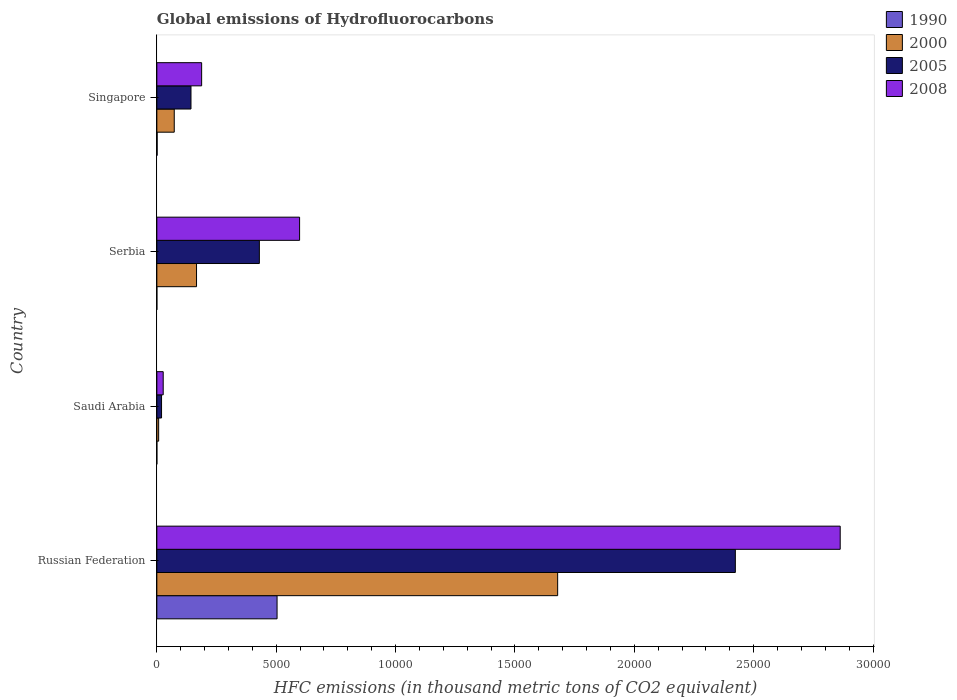Are the number of bars per tick equal to the number of legend labels?
Make the answer very short. Yes. Are the number of bars on each tick of the Y-axis equal?
Your answer should be compact. Yes. How many bars are there on the 2nd tick from the bottom?
Your answer should be compact. 4. What is the label of the 4th group of bars from the top?
Keep it short and to the point. Russian Federation. What is the global emissions of Hydrofluorocarbons in 2005 in Singapore?
Ensure brevity in your answer.  1429.7. Across all countries, what is the maximum global emissions of Hydrofluorocarbons in 2005?
Offer a terse response. 2.42e+04. Across all countries, what is the minimum global emissions of Hydrofluorocarbons in 2005?
Provide a short and direct response. 196.9. In which country was the global emissions of Hydrofluorocarbons in 2008 maximum?
Make the answer very short. Russian Federation. In which country was the global emissions of Hydrofluorocarbons in 2008 minimum?
Provide a succinct answer. Saudi Arabia. What is the total global emissions of Hydrofluorocarbons in 2008 in the graph?
Your response must be concise. 3.67e+04. What is the difference between the global emissions of Hydrofluorocarbons in 1990 in Russian Federation and that in Serbia?
Your answer should be compact. 5035.1. What is the difference between the global emissions of Hydrofluorocarbons in 2005 in Serbia and the global emissions of Hydrofluorocarbons in 1990 in Saudi Arabia?
Provide a succinct answer. 4293.7. What is the average global emissions of Hydrofluorocarbons in 2008 per country?
Your answer should be compact. 9186.35. What is the difference between the global emissions of Hydrofluorocarbons in 2008 and global emissions of Hydrofluorocarbons in 1990 in Saudi Arabia?
Make the answer very short. 266.4. In how many countries, is the global emissions of Hydrofluorocarbons in 2005 greater than 5000 thousand metric tons?
Your response must be concise. 1. What is the ratio of the global emissions of Hydrofluorocarbons in 1990 in Russian Federation to that in Singapore?
Ensure brevity in your answer.  399.65. Is the difference between the global emissions of Hydrofluorocarbons in 2008 in Saudi Arabia and Singapore greater than the difference between the global emissions of Hydrofluorocarbons in 1990 in Saudi Arabia and Singapore?
Your answer should be compact. No. What is the difference between the highest and the second highest global emissions of Hydrofluorocarbons in 2005?
Offer a very short reply. 1.99e+04. What is the difference between the highest and the lowest global emissions of Hydrofluorocarbons in 2005?
Your response must be concise. 2.40e+04. Is the sum of the global emissions of Hydrofluorocarbons in 2005 in Saudi Arabia and Serbia greater than the maximum global emissions of Hydrofluorocarbons in 2000 across all countries?
Your answer should be compact. No. Is it the case that in every country, the sum of the global emissions of Hydrofluorocarbons in 1990 and global emissions of Hydrofluorocarbons in 2008 is greater than the sum of global emissions of Hydrofluorocarbons in 2005 and global emissions of Hydrofluorocarbons in 2000?
Your answer should be compact. Yes. What does the 1st bar from the bottom in Singapore represents?
Keep it short and to the point. 1990. Is it the case that in every country, the sum of the global emissions of Hydrofluorocarbons in 2000 and global emissions of Hydrofluorocarbons in 1990 is greater than the global emissions of Hydrofluorocarbons in 2008?
Provide a short and direct response. No. How many bars are there?
Offer a terse response. 16. How many countries are there in the graph?
Ensure brevity in your answer.  4. What is the difference between two consecutive major ticks on the X-axis?
Make the answer very short. 5000. Does the graph contain any zero values?
Offer a very short reply. No. Does the graph contain grids?
Your answer should be very brief. No. Where does the legend appear in the graph?
Make the answer very short. Top right. How many legend labels are there?
Provide a short and direct response. 4. What is the title of the graph?
Give a very brief answer. Global emissions of Hydrofluorocarbons. What is the label or title of the X-axis?
Offer a very short reply. HFC emissions (in thousand metric tons of CO2 equivalent). What is the HFC emissions (in thousand metric tons of CO2 equivalent) in 1990 in Russian Federation?
Provide a short and direct response. 5035.6. What is the HFC emissions (in thousand metric tons of CO2 equivalent) of 2000 in Russian Federation?
Your response must be concise. 1.68e+04. What is the HFC emissions (in thousand metric tons of CO2 equivalent) in 2005 in Russian Federation?
Ensure brevity in your answer.  2.42e+04. What is the HFC emissions (in thousand metric tons of CO2 equivalent) in 2008 in Russian Federation?
Provide a succinct answer. 2.86e+04. What is the HFC emissions (in thousand metric tons of CO2 equivalent) in 1990 in Saudi Arabia?
Your answer should be very brief. 0.1. What is the HFC emissions (in thousand metric tons of CO2 equivalent) of 2000 in Saudi Arabia?
Offer a terse response. 75.5. What is the HFC emissions (in thousand metric tons of CO2 equivalent) in 2005 in Saudi Arabia?
Offer a terse response. 196.9. What is the HFC emissions (in thousand metric tons of CO2 equivalent) of 2008 in Saudi Arabia?
Provide a short and direct response. 266.5. What is the HFC emissions (in thousand metric tons of CO2 equivalent) of 2000 in Serbia?
Provide a succinct answer. 1662. What is the HFC emissions (in thousand metric tons of CO2 equivalent) of 2005 in Serbia?
Provide a succinct answer. 4293.8. What is the HFC emissions (in thousand metric tons of CO2 equivalent) in 2008 in Serbia?
Offer a terse response. 5979. What is the HFC emissions (in thousand metric tons of CO2 equivalent) in 1990 in Singapore?
Keep it short and to the point. 12.6. What is the HFC emissions (in thousand metric tons of CO2 equivalent) of 2000 in Singapore?
Offer a terse response. 728.9. What is the HFC emissions (in thousand metric tons of CO2 equivalent) of 2005 in Singapore?
Keep it short and to the point. 1429.7. What is the HFC emissions (in thousand metric tons of CO2 equivalent) in 2008 in Singapore?
Offer a very short reply. 1876.4. Across all countries, what is the maximum HFC emissions (in thousand metric tons of CO2 equivalent) of 1990?
Provide a short and direct response. 5035.6. Across all countries, what is the maximum HFC emissions (in thousand metric tons of CO2 equivalent) of 2000?
Ensure brevity in your answer.  1.68e+04. Across all countries, what is the maximum HFC emissions (in thousand metric tons of CO2 equivalent) of 2005?
Offer a terse response. 2.42e+04. Across all countries, what is the maximum HFC emissions (in thousand metric tons of CO2 equivalent) in 2008?
Provide a short and direct response. 2.86e+04. Across all countries, what is the minimum HFC emissions (in thousand metric tons of CO2 equivalent) in 1990?
Provide a succinct answer. 0.1. Across all countries, what is the minimum HFC emissions (in thousand metric tons of CO2 equivalent) of 2000?
Provide a short and direct response. 75.5. Across all countries, what is the minimum HFC emissions (in thousand metric tons of CO2 equivalent) in 2005?
Your answer should be compact. 196.9. Across all countries, what is the minimum HFC emissions (in thousand metric tons of CO2 equivalent) in 2008?
Your answer should be very brief. 266.5. What is the total HFC emissions (in thousand metric tons of CO2 equivalent) in 1990 in the graph?
Offer a terse response. 5048.8. What is the total HFC emissions (in thousand metric tons of CO2 equivalent) of 2000 in the graph?
Your response must be concise. 1.93e+04. What is the total HFC emissions (in thousand metric tons of CO2 equivalent) of 2005 in the graph?
Provide a short and direct response. 3.02e+04. What is the total HFC emissions (in thousand metric tons of CO2 equivalent) in 2008 in the graph?
Your answer should be compact. 3.67e+04. What is the difference between the HFC emissions (in thousand metric tons of CO2 equivalent) in 1990 in Russian Federation and that in Saudi Arabia?
Your answer should be very brief. 5035.5. What is the difference between the HFC emissions (in thousand metric tons of CO2 equivalent) of 2000 in Russian Federation and that in Saudi Arabia?
Make the answer very short. 1.67e+04. What is the difference between the HFC emissions (in thousand metric tons of CO2 equivalent) in 2005 in Russian Federation and that in Saudi Arabia?
Offer a very short reply. 2.40e+04. What is the difference between the HFC emissions (in thousand metric tons of CO2 equivalent) of 2008 in Russian Federation and that in Saudi Arabia?
Offer a terse response. 2.84e+04. What is the difference between the HFC emissions (in thousand metric tons of CO2 equivalent) of 1990 in Russian Federation and that in Serbia?
Make the answer very short. 5035.1. What is the difference between the HFC emissions (in thousand metric tons of CO2 equivalent) in 2000 in Russian Federation and that in Serbia?
Your response must be concise. 1.51e+04. What is the difference between the HFC emissions (in thousand metric tons of CO2 equivalent) of 2005 in Russian Federation and that in Serbia?
Your answer should be very brief. 1.99e+04. What is the difference between the HFC emissions (in thousand metric tons of CO2 equivalent) of 2008 in Russian Federation and that in Serbia?
Ensure brevity in your answer.  2.26e+04. What is the difference between the HFC emissions (in thousand metric tons of CO2 equivalent) in 1990 in Russian Federation and that in Singapore?
Keep it short and to the point. 5023. What is the difference between the HFC emissions (in thousand metric tons of CO2 equivalent) in 2000 in Russian Federation and that in Singapore?
Offer a terse response. 1.61e+04. What is the difference between the HFC emissions (in thousand metric tons of CO2 equivalent) of 2005 in Russian Federation and that in Singapore?
Offer a terse response. 2.28e+04. What is the difference between the HFC emissions (in thousand metric tons of CO2 equivalent) in 2008 in Russian Federation and that in Singapore?
Make the answer very short. 2.67e+04. What is the difference between the HFC emissions (in thousand metric tons of CO2 equivalent) in 2000 in Saudi Arabia and that in Serbia?
Make the answer very short. -1586.5. What is the difference between the HFC emissions (in thousand metric tons of CO2 equivalent) in 2005 in Saudi Arabia and that in Serbia?
Provide a succinct answer. -4096.9. What is the difference between the HFC emissions (in thousand metric tons of CO2 equivalent) in 2008 in Saudi Arabia and that in Serbia?
Your answer should be very brief. -5712.5. What is the difference between the HFC emissions (in thousand metric tons of CO2 equivalent) in 2000 in Saudi Arabia and that in Singapore?
Your answer should be very brief. -653.4. What is the difference between the HFC emissions (in thousand metric tons of CO2 equivalent) of 2005 in Saudi Arabia and that in Singapore?
Ensure brevity in your answer.  -1232.8. What is the difference between the HFC emissions (in thousand metric tons of CO2 equivalent) in 2008 in Saudi Arabia and that in Singapore?
Provide a succinct answer. -1609.9. What is the difference between the HFC emissions (in thousand metric tons of CO2 equivalent) in 2000 in Serbia and that in Singapore?
Provide a short and direct response. 933.1. What is the difference between the HFC emissions (in thousand metric tons of CO2 equivalent) of 2005 in Serbia and that in Singapore?
Keep it short and to the point. 2864.1. What is the difference between the HFC emissions (in thousand metric tons of CO2 equivalent) in 2008 in Serbia and that in Singapore?
Offer a terse response. 4102.6. What is the difference between the HFC emissions (in thousand metric tons of CO2 equivalent) of 1990 in Russian Federation and the HFC emissions (in thousand metric tons of CO2 equivalent) of 2000 in Saudi Arabia?
Offer a terse response. 4960.1. What is the difference between the HFC emissions (in thousand metric tons of CO2 equivalent) of 1990 in Russian Federation and the HFC emissions (in thousand metric tons of CO2 equivalent) of 2005 in Saudi Arabia?
Provide a short and direct response. 4838.7. What is the difference between the HFC emissions (in thousand metric tons of CO2 equivalent) in 1990 in Russian Federation and the HFC emissions (in thousand metric tons of CO2 equivalent) in 2008 in Saudi Arabia?
Offer a very short reply. 4769.1. What is the difference between the HFC emissions (in thousand metric tons of CO2 equivalent) in 2000 in Russian Federation and the HFC emissions (in thousand metric tons of CO2 equivalent) in 2005 in Saudi Arabia?
Make the answer very short. 1.66e+04. What is the difference between the HFC emissions (in thousand metric tons of CO2 equivalent) of 2000 in Russian Federation and the HFC emissions (in thousand metric tons of CO2 equivalent) of 2008 in Saudi Arabia?
Your answer should be compact. 1.65e+04. What is the difference between the HFC emissions (in thousand metric tons of CO2 equivalent) in 2005 in Russian Federation and the HFC emissions (in thousand metric tons of CO2 equivalent) in 2008 in Saudi Arabia?
Keep it short and to the point. 2.40e+04. What is the difference between the HFC emissions (in thousand metric tons of CO2 equivalent) in 1990 in Russian Federation and the HFC emissions (in thousand metric tons of CO2 equivalent) in 2000 in Serbia?
Keep it short and to the point. 3373.6. What is the difference between the HFC emissions (in thousand metric tons of CO2 equivalent) in 1990 in Russian Federation and the HFC emissions (in thousand metric tons of CO2 equivalent) in 2005 in Serbia?
Give a very brief answer. 741.8. What is the difference between the HFC emissions (in thousand metric tons of CO2 equivalent) in 1990 in Russian Federation and the HFC emissions (in thousand metric tons of CO2 equivalent) in 2008 in Serbia?
Provide a short and direct response. -943.4. What is the difference between the HFC emissions (in thousand metric tons of CO2 equivalent) of 2000 in Russian Federation and the HFC emissions (in thousand metric tons of CO2 equivalent) of 2005 in Serbia?
Your answer should be compact. 1.25e+04. What is the difference between the HFC emissions (in thousand metric tons of CO2 equivalent) in 2000 in Russian Federation and the HFC emissions (in thousand metric tons of CO2 equivalent) in 2008 in Serbia?
Offer a terse response. 1.08e+04. What is the difference between the HFC emissions (in thousand metric tons of CO2 equivalent) of 2005 in Russian Federation and the HFC emissions (in thousand metric tons of CO2 equivalent) of 2008 in Serbia?
Your response must be concise. 1.83e+04. What is the difference between the HFC emissions (in thousand metric tons of CO2 equivalent) of 1990 in Russian Federation and the HFC emissions (in thousand metric tons of CO2 equivalent) of 2000 in Singapore?
Keep it short and to the point. 4306.7. What is the difference between the HFC emissions (in thousand metric tons of CO2 equivalent) of 1990 in Russian Federation and the HFC emissions (in thousand metric tons of CO2 equivalent) of 2005 in Singapore?
Keep it short and to the point. 3605.9. What is the difference between the HFC emissions (in thousand metric tons of CO2 equivalent) of 1990 in Russian Federation and the HFC emissions (in thousand metric tons of CO2 equivalent) of 2008 in Singapore?
Offer a terse response. 3159.2. What is the difference between the HFC emissions (in thousand metric tons of CO2 equivalent) of 2000 in Russian Federation and the HFC emissions (in thousand metric tons of CO2 equivalent) of 2005 in Singapore?
Make the answer very short. 1.54e+04. What is the difference between the HFC emissions (in thousand metric tons of CO2 equivalent) in 2000 in Russian Federation and the HFC emissions (in thousand metric tons of CO2 equivalent) in 2008 in Singapore?
Your answer should be very brief. 1.49e+04. What is the difference between the HFC emissions (in thousand metric tons of CO2 equivalent) in 2005 in Russian Federation and the HFC emissions (in thousand metric tons of CO2 equivalent) in 2008 in Singapore?
Offer a terse response. 2.24e+04. What is the difference between the HFC emissions (in thousand metric tons of CO2 equivalent) of 1990 in Saudi Arabia and the HFC emissions (in thousand metric tons of CO2 equivalent) of 2000 in Serbia?
Your response must be concise. -1661.9. What is the difference between the HFC emissions (in thousand metric tons of CO2 equivalent) of 1990 in Saudi Arabia and the HFC emissions (in thousand metric tons of CO2 equivalent) of 2005 in Serbia?
Ensure brevity in your answer.  -4293.7. What is the difference between the HFC emissions (in thousand metric tons of CO2 equivalent) of 1990 in Saudi Arabia and the HFC emissions (in thousand metric tons of CO2 equivalent) of 2008 in Serbia?
Make the answer very short. -5978.9. What is the difference between the HFC emissions (in thousand metric tons of CO2 equivalent) of 2000 in Saudi Arabia and the HFC emissions (in thousand metric tons of CO2 equivalent) of 2005 in Serbia?
Make the answer very short. -4218.3. What is the difference between the HFC emissions (in thousand metric tons of CO2 equivalent) in 2000 in Saudi Arabia and the HFC emissions (in thousand metric tons of CO2 equivalent) in 2008 in Serbia?
Make the answer very short. -5903.5. What is the difference between the HFC emissions (in thousand metric tons of CO2 equivalent) of 2005 in Saudi Arabia and the HFC emissions (in thousand metric tons of CO2 equivalent) of 2008 in Serbia?
Ensure brevity in your answer.  -5782.1. What is the difference between the HFC emissions (in thousand metric tons of CO2 equivalent) of 1990 in Saudi Arabia and the HFC emissions (in thousand metric tons of CO2 equivalent) of 2000 in Singapore?
Ensure brevity in your answer.  -728.8. What is the difference between the HFC emissions (in thousand metric tons of CO2 equivalent) of 1990 in Saudi Arabia and the HFC emissions (in thousand metric tons of CO2 equivalent) of 2005 in Singapore?
Give a very brief answer. -1429.6. What is the difference between the HFC emissions (in thousand metric tons of CO2 equivalent) in 1990 in Saudi Arabia and the HFC emissions (in thousand metric tons of CO2 equivalent) in 2008 in Singapore?
Offer a very short reply. -1876.3. What is the difference between the HFC emissions (in thousand metric tons of CO2 equivalent) of 2000 in Saudi Arabia and the HFC emissions (in thousand metric tons of CO2 equivalent) of 2005 in Singapore?
Offer a very short reply. -1354.2. What is the difference between the HFC emissions (in thousand metric tons of CO2 equivalent) in 2000 in Saudi Arabia and the HFC emissions (in thousand metric tons of CO2 equivalent) in 2008 in Singapore?
Provide a succinct answer. -1800.9. What is the difference between the HFC emissions (in thousand metric tons of CO2 equivalent) of 2005 in Saudi Arabia and the HFC emissions (in thousand metric tons of CO2 equivalent) of 2008 in Singapore?
Your answer should be very brief. -1679.5. What is the difference between the HFC emissions (in thousand metric tons of CO2 equivalent) in 1990 in Serbia and the HFC emissions (in thousand metric tons of CO2 equivalent) in 2000 in Singapore?
Keep it short and to the point. -728.4. What is the difference between the HFC emissions (in thousand metric tons of CO2 equivalent) in 1990 in Serbia and the HFC emissions (in thousand metric tons of CO2 equivalent) in 2005 in Singapore?
Offer a very short reply. -1429.2. What is the difference between the HFC emissions (in thousand metric tons of CO2 equivalent) of 1990 in Serbia and the HFC emissions (in thousand metric tons of CO2 equivalent) of 2008 in Singapore?
Give a very brief answer. -1875.9. What is the difference between the HFC emissions (in thousand metric tons of CO2 equivalent) of 2000 in Serbia and the HFC emissions (in thousand metric tons of CO2 equivalent) of 2005 in Singapore?
Provide a short and direct response. 232.3. What is the difference between the HFC emissions (in thousand metric tons of CO2 equivalent) in 2000 in Serbia and the HFC emissions (in thousand metric tons of CO2 equivalent) in 2008 in Singapore?
Your answer should be very brief. -214.4. What is the difference between the HFC emissions (in thousand metric tons of CO2 equivalent) of 2005 in Serbia and the HFC emissions (in thousand metric tons of CO2 equivalent) of 2008 in Singapore?
Ensure brevity in your answer.  2417.4. What is the average HFC emissions (in thousand metric tons of CO2 equivalent) in 1990 per country?
Make the answer very short. 1262.2. What is the average HFC emissions (in thousand metric tons of CO2 equivalent) in 2000 per country?
Keep it short and to the point. 4813.77. What is the average HFC emissions (in thousand metric tons of CO2 equivalent) of 2005 per country?
Provide a short and direct response. 7537.93. What is the average HFC emissions (in thousand metric tons of CO2 equivalent) in 2008 per country?
Your answer should be compact. 9186.35. What is the difference between the HFC emissions (in thousand metric tons of CO2 equivalent) of 1990 and HFC emissions (in thousand metric tons of CO2 equivalent) of 2000 in Russian Federation?
Your answer should be very brief. -1.18e+04. What is the difference between the HFC emissions (in thousand metric tons of CO2 equivalent) of 1990 and HFC emissions (in thousand metric tons of CO2 equivalent) of 2005 in Russian Federation?
Your response must be concise. -1.92e+04. What is the difference between the HFC emissions (in thousand metric tons of CO2 equivalent) in 1990 and HFC emissions (in thousand metric tons of CO2 equivalent) in 2008 in Russian Federation?
Provide a succinct answer. -2.36e+04. What is the difference between the HFC emissions (in thousand metric tons of CO2 equivalent) in 2000 and HFC emissions (in thousand metric tons of CO2 equivalent) in 2005 in Russian Federation?
Your answer should be very brief. -7442.6. What is the difference between the HFC emissions (in thousand metric tons of CO2 equivalent) of 2000 and HFC emissions (in thousand metric tons of CO2 equivalent) of 2008 in Russian Federation?
Give a very brief answer. -1.18e+04. What is the difference between the HFC emissions (in thousand metric tons of CO2 equivalent) in 2005 and HFC emissions (in thousand metric tons of CO2 equivalent) in 2008 in Russian Federation?
Your response must be concise. -4392.2. What is the difference between the HFC emissions (in thousand metric tons of CO2 equivalent) of 1990 and HFC emissions (in thousand metric tons of CO2 equivalent) of 2000 in Saudi Arabia?
Ensure brevity in your answer.  -75.4. What is the difference between the HFC emissions (in thousand metric tons of CO2 equivalent) in 1990 and HFC emissions (in thousand metric tons of CO2 equivalent) in 2005 in Saudi Arabia?
Give a very brief answer. -196.8. What is the difference between the HFC emissions (in thousand metric tons of CO2 equivalent) in 1990 and HFC emissions (in thousand metric tons of CO2 equivalent) in 2008 in Saudi Arabia?
Your answer should be compact. -266.4. What is the difference between the HFC emissions (in thousand metric tons of CO2 equivalent) in 2000 and HFC emissions (in thousand metric tons of CO2 equivalent) in 2005 in Saudi Arabia?
Make the answer very short. -121.4. What is the difference between the HFC emissions (in thousand metric tons of CO2 equivalent) in 2000 and HFC emissions (in thousand metric tons of CO2 equivalent) in 2008 in Saudi Arabia?
Provide a short and direct response. -191. What is the difference between the HFC emissions (in thousand metric tons of CO2 equivalent) of 2005 and HFC emissions (in thousand metric tons of CO2 equivalent) of 2008 in Saudi Arabia?
Provide a succinct answer. -69.6. What is the difference between the HFC emissions (in thousand metric tons of CO2 equivalent) of 1990 and HFC emissions (in thousand metric tons of CO2 equivalent) of 2000 in Serbia?
Your answer should be very brief. -1661.5. What is the difference between the HFC emissions (in thousand metric tons of CO2 equivalent) in 1990 and HFC emissions (in thousand metric tons of CO2 equivalent) in 2005 in Serbia?
Provide a succinct answer. -4293.3. What is the difference between the HFC emissions (in thousand metric tons of CO2 equivalent) in 1990 and HFC emissions (in thousand metric tons of CO2 equivalent) in 2008 in Serbia?
Your response must be concise. -5978.5. What is the difference between the HFC emissions (in thousand metric tons of CO2 equivalent) of 2000 and HFC emissions (in thousand metric tons of CO2 equivalent) of 2005 in Serbia?
Your answer should be compact. -2631.8. What is the difference between the HFC emissions (in thousand metric tons of CO2 equivalent) in 2000 and HFC emissions (in thousand metric tons of CO2 equivalent) in 2008 in Serbia?
Ensure brevity in your answer.  -4317. What is the difference between the HFC emissions (in thousand metric tons of CO2 equivalent) in 2005 and HFC emissions (in thousand metric tons of CO2 equivalent) in 2008 in Serbia?
Provide a succinct answer. -1685.2. What is the difference between the HFC emissions (in thousand metric tons of CO2 equivalent) in 1990 and HFC emissions (in thousand metric tons of CO2 equivalent) in 2000 in Singapore?
Your answer should be very brief. -716.3. What is the difference between the HFC emissions (in thousand metric tons of CO2 equivalent) of 1990 and HFC emissions (in thousand metric tons of CO2 equivalent) of 2005 in Singapore?
Your answer should be very brief. -1417.1. What is the difference between the HFC emissions (in thousand metric tons of CO2 equivalent) of 1990 and HFC emissions (in thousand metric tons of CO2 equivalent) of 2008 in Singapore?
Provide a succinct answer. -1863.8. What is the difference between the HFC emissions (in thousand metric tons of CO2 equivalent) of 2000 and HFC emissions (in thousand metric tons of CO2 equivalent) of 2005 in Singapore?
Offer a terse response. -700.8. What is the difference between the HFC emissions (in thousand metric tons of CO2 equivalent) of 2000 and HFC emissions (in thousand metric tons of CO2 equivalent) of 2008 in Singapore?
Provide a short and direct response. -1147.5. What is the difference between the HFC emissions (in thousand metric tons of CO2 equivalent) in 2005 and HFC emissions (in thousand metric tons of CO2 equivalent) in 2008 in Singapore?
Make the answer very short. -446.7. What is the ratio of the HFC emissions (in thousand metric tons of CO2 equivalent) of 1990 in Russian Federation to that in Saudi Arabia?
Your answer should be compact. 5.04e+04. What is the ratio of the HFC emissions (in thousand metric tons of CO2 equivalent) in 2000 in Russian Federation to that in Saudi Arabia?
Ensure brevity in your answer.  222.37. What is the ratio of the HFC emissions (in thousand metric tons of CO2 equivalent) in 2005 in Russian Federation to that in Saudi Arabia?
Offer a terse response. 123.06. What is the ratio of the HFC emissions (in thousand metric tons of CO2 equivalent) of 2008 in Russian Federation to that in Saudi Arabia?
Ensure brevity in your answer.  107.41. What is the ratio of the HFC emissions (in thousand metric tons of CO2 equivalent) of 1990 in Russian Federation to that in Serbia?
Give a very brief answer. 1.01e+04. What is the ratio of the HFC emissions (in thousand metric tons of CO2 equivalent) of 2000 in Russian Federation to that in Serbia?
Keep it short and to the point. 10.1. What is the ratio of the HFC emissions (in thousand metric tons of CO2 equivalent) of 2005 in Russian Federation to that in Serbia?
Offer a very short reply. 5.64. What is the ratio of the HFC emissions (in thousand metric tons of CO2 equivalent) of 2008 in Russian Federation to that in Serbia?
Give a very brief answer. 4.79. What is the ratio of the HFC emissions (in thousand metric tons of CO2 equivalent) in 1990 in Russian Federation to that in Singapore?
Your response must be concise. 399.65. What is the ratio of the HFC emissions (in thousand metric tons of CO2 equivalent) of 2000 in Russian Federation to that in Singapore?
Keep it short and to the point. 23.03. What is the ratio of the HFC emissions (in thousand metric tons of CO2 equivalent) of 2005 in Russian Federation to that in Singapore?
Your response must be concise. 16.95. What is the ratio of the HFC emissions (in thousand metric tons of CO2 equivalent) of 2008 in Russian Federation to that in Singapore?
Your response must be concise. 15.25. What is the ratio of the HFC emissions (in thousand metric tons of CO2 equivalent) in 1990 in Saudi Arabia to that in Serbia?
Your response must be concise. 0.2. What is the ratio of the HFC emissions (in thousand metric tons of CO2 equivalent) of 2000 in Saudi Arabia to that in Serbia?
Ensure brevity in your answer.  0.05. What is the ratio of the HFC emissions (in thousand metric tons of CO2 equivalent) of 2005 in Saudi Arabia to that in Serbia?
Your answer should be very brief. 0.05. What is the ratio of the HFC emissions (in thousand metric tons of CO2 equivalent) in 2008 in Saudi Arabia to that in Serbia?
Your response must be concise. 0.04. What is the ratio of the HFC emissions (in thousand metric tons of CO2 equivalent) in 1990 in Saudi Arabia to that in Singapore?
Give a very brief answer. 0.01. What is the ratio of the HFC emissions (in thousand metric tons of CO2 equivalent) in 2000 in Saudi Arabia to that in Singapore?
Make the answer very short. 0.1. What is the ratio of the HFC emissions (in thousand metric tons of CO2 equivalent) of 2005 in Saudi Arabia to that in Singapore?
Your response must be concise. 0.14. What is the ratio of the HFC emissions (in thousand metric tons of CO2 equivalent) in 2008 in Saudi Arabia to that in Singapore?
Your answer should be compact. 0.14. What is the ratio of the HFC emissions (in thousand metric tons of CO2 equivalent) of 1990 in Serbia to that in Singapore?
Offer a very short reply. 0.04. What is the ratio of the HFC emissions (in thousand metric tons of CO2 equivalent) in 2000 in Serbia to that in Singapore?
Your answer should be very brief. 2.28. What is the ratio of the HFC emissions (in thousand metric tons of CO2 equivalent) in 2005 in Serbia to that in Singapore?
Make the answer very short. 3. What is the ratio of the HFC emissions (in thousand metric tons of CO2 equivalent) of 2008 in Serbia to that in Singapore?
Keep it short and to the point. 3.19. What is the difference between the highest and the second highest HFC emissions (in thousand metric tons of CO2 equivalent) in 1990?
Ensure brevity in your answer.  5023. What is the difference between the highest and the second highest HFC emissions (in thousand metric tons of CO2 equivalent) of 2000?
Your answer should be compact. 1.51e+04. What is the difference between the highest and the second highest HFC emissions (in thousand metric tons of CO2 equivalent) in 2005?
Your answer should be very brief. 1.99e+04. What is the difference between the highest and the second highest HFC emissions (in thousand metric tons of CO2 equivalent) in 2008?
Your response must be concise. 2.26e+04. What is the difference between the highest and the lowest HFC emissions (in thousand metric tons of CO2 equivalent) of 1990?
Provide a succinct answer. 5035.5. What is the difference between the highest and the lowest HFC emissions (in thousand metric tons of CO2 equivalent) of 2000?
Provide a succinct answer. 1.67e+04. What is the difference between the highest and the lowest HFC emissions (in thousand metric tons of CO2 equivalent) of 2005?
Give a very brief answer. 2.40e+04. What is the difference between the highest and the lowest HFC emissions (in thousand metric tons of CO2 equivalent) of 2008?
Provide a succinct answer. 2.84e+04. 